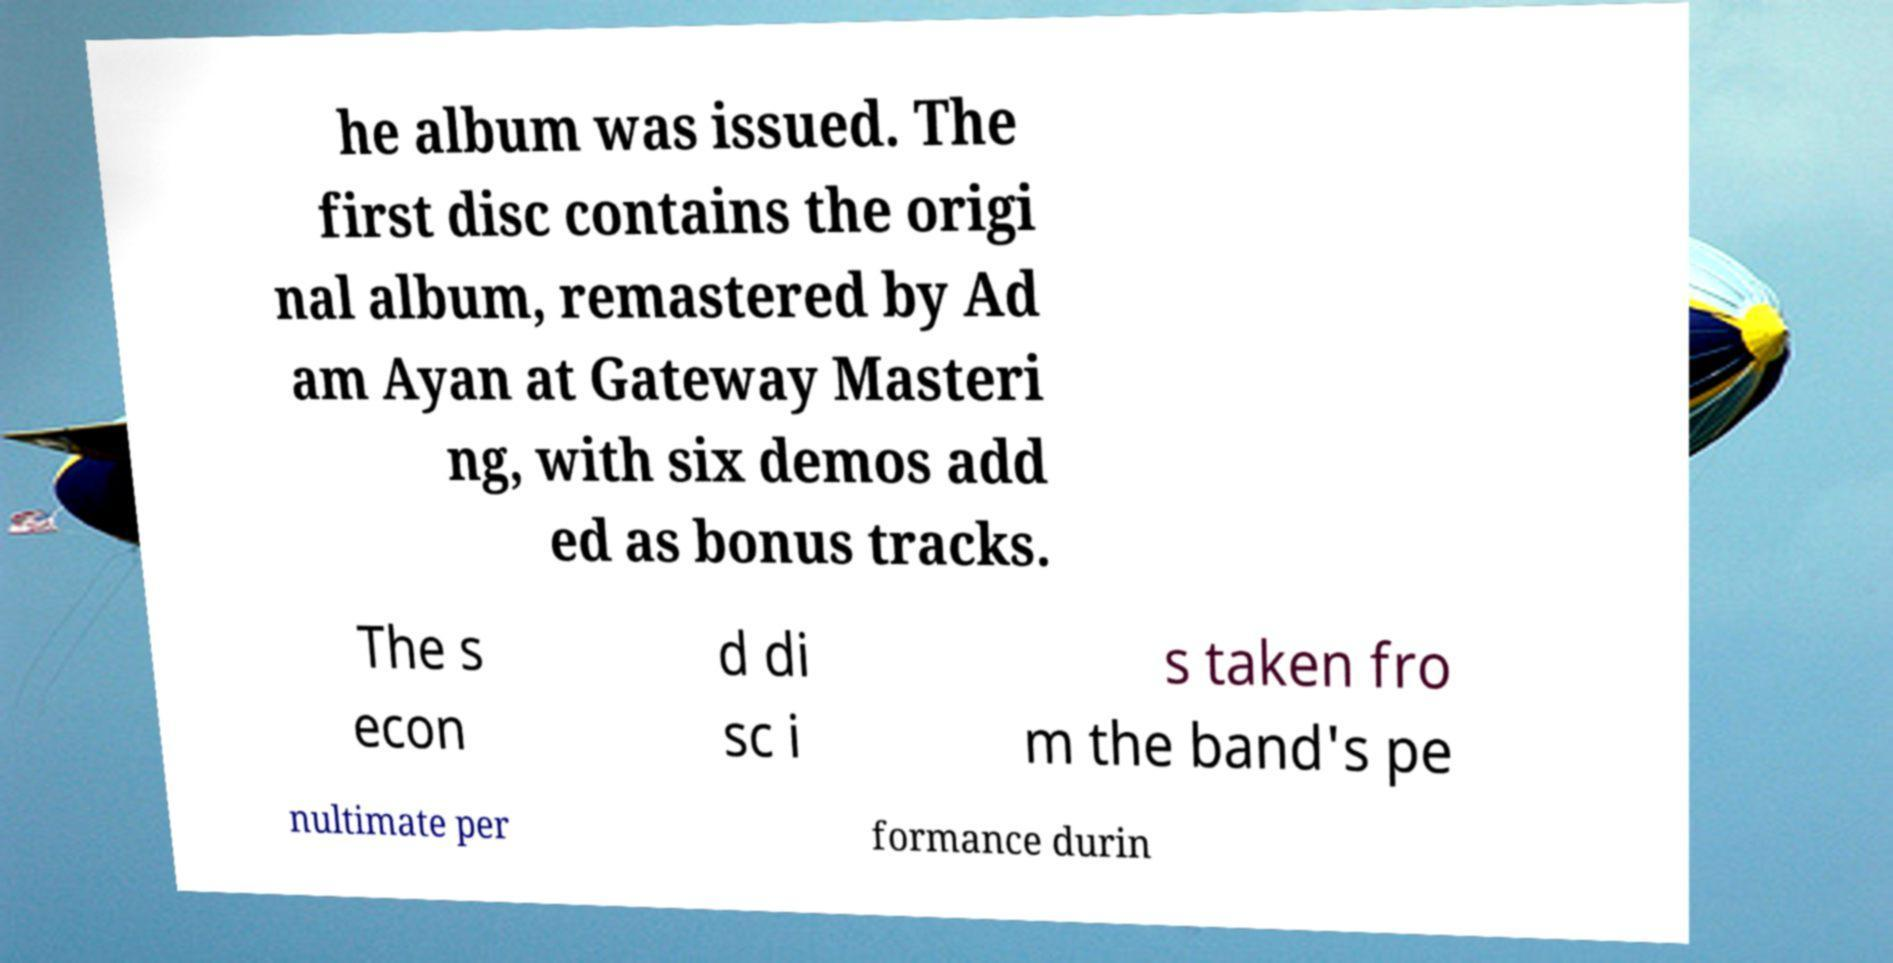Could you extract and type out the text from this image? he album was issued. The first disc contains the origi nal album, remastered by Ad am Ayan at Gateway Masteri ng, with six demos add ed as bonus tracks. The s econ d di sc i s taken fro m the band's pe nultimate per formance durin 